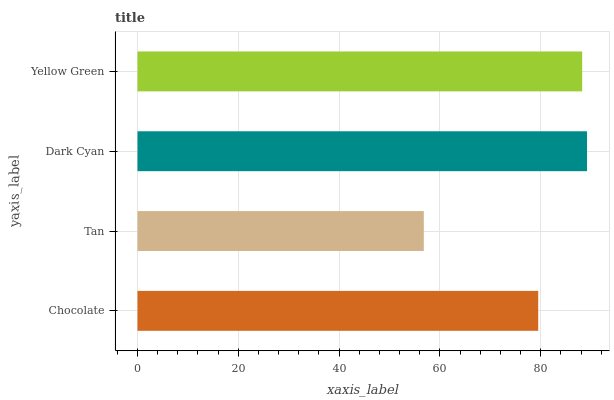Is Tan the minimum?
Answer yes or no. Yes. Is Dark Cyan the maximum?
Answer yes or no. Yes. Is Dark Cyan the minimum?
Answer yes or no. No. Is Tan the maximum?
Answer yes or no. No. Is Dark Cyan greater than Tan?
Answer yes or no. Yes. Is Tan less than Dark Cyan?
Answer yes or no. Yes. Is Tan greater than Dark Cyan?
Answer yes or no. No. Is Dark Cyan less than Tan?
Answer yes or no. No. Is Yellow Green the high median?
Answer yes or no. Yes. Is Chocolate the low median?
Answer yes or no. Yes. Is Tan the high median?
Answer yes or no. No. Is Tan the low median?
Answer yes or no. No. 